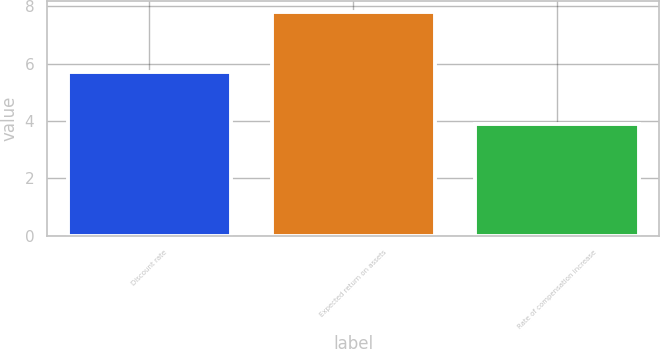Convert chart to OTSL. <chart><loc_0><loc_0><loc_500><loc_500><bar_chart><fcel>Discount rate<fcel>Expected return on assets<fcel>Rate of compensation increase<nl><fcel>5.7<fcel>7.8<fcel>3.9<nl></chart> 